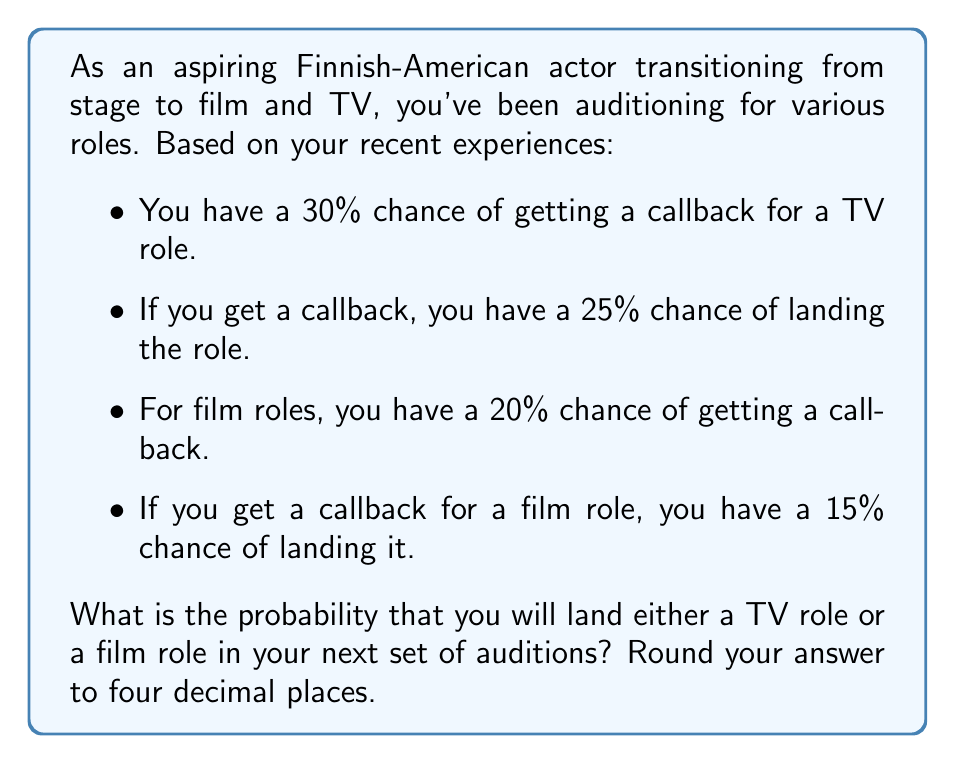Solve this math problem. Let's approach this step-by-step using the concept of probability:

1. For TV roles:
   - Probability of getting a callback = 0.30
   - Probability of landing the role given a callback = 0.25
   - Probability of landing a TV role = $0.30 \times 0.25 = 0.075$ or 7.5%

2. For film roles:
   - Probability of getting a callback = 0.20
   - Probability of landing the role given a callback = 0.15
   - Probability of landing a film role = $0.20 \times 0.15 = 0.03$ or 3%

3. To find the probability of landing either a TV role or a film role, we need to add these probabilities together:

   $$P(\text{TV or Film}) = P(\text{TV}) + P(\text{Film}) - P(\text{TV and Film})$$

   However, since landing a TV role and landing a film role are mutually exclusive events (you can't land both simultaneously), the probability of both occurring is 0.

   So, $$P(\text{TV or Film}) = P(\text{TV}) + P(\text{Film})$$

4. Calculating the final probability:
   $$P(\text{TV or Film}) = 0.075 + 0.03 = 0.105$$

5. Rounding to four decimal places:
   $$0.105 \approx 0.1050$$
Answer: 0.1050 